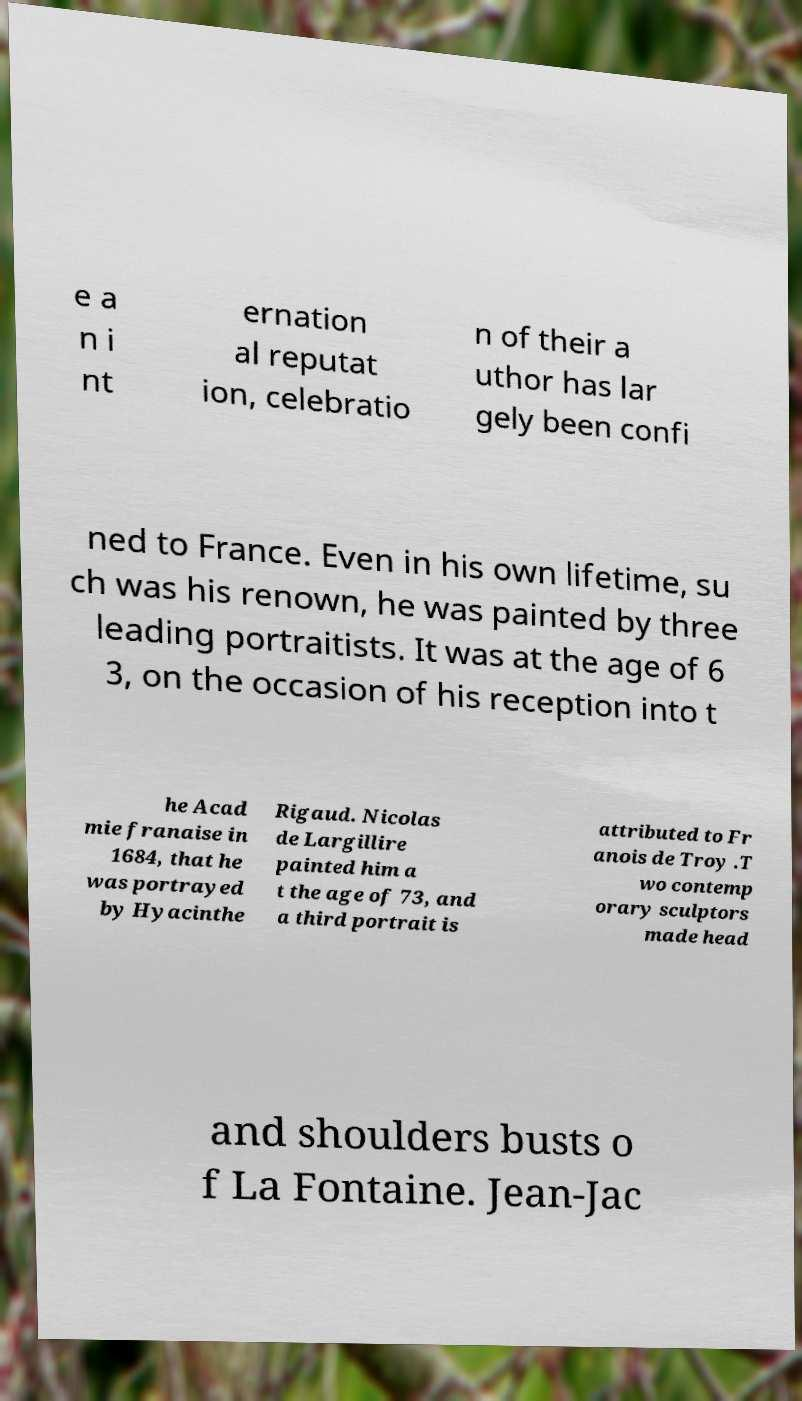For documentation purposes, I need the text within this image transcribed. Could you provide that? e a n i nt ernation al reputat ion, celebratio n of their a uthor has lar gely been confi ned to France. Even in his own lifetime, su ch was his renown, he was painted by three leading portraitists. It was at the age of 6 3, on the occasion of his reception into t he Acad mie franaise in 1684, that he was portrayed by Hyacinthe Rigaud. Nicolas de Largillire painted him a t the age of 73, and a third portrait is attributed to Fr anois de Troy .T wo contemp orary sculptors made head and shoulders busts o f La Fontaine. Jean-Jac 